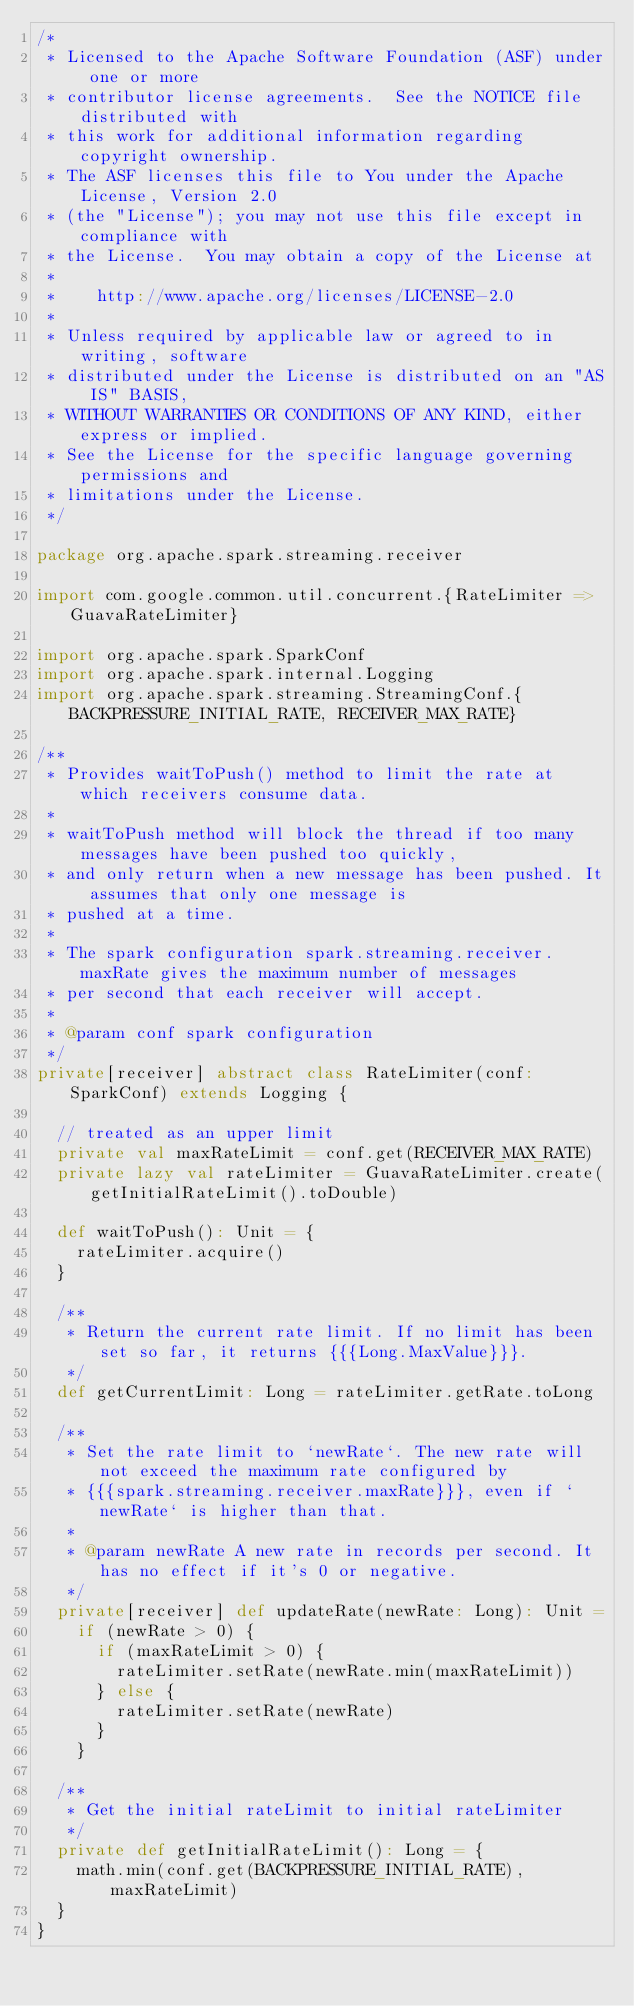<code> <loc_0><loc_0><loc_500><loc_500><_Scala_>/*
 * Licensed to the Apache Software Foundation (ASF) under one or more
 * contributor license agreements.  See the NOTICE file distributed with
 * this work for additional information regarding copyright ownership.
 * The ASF licenses this file to You under the Apache License, Version 2.0
 * (the "License"); you may not use this file except in compliance with
 * the License.  You may obtain a copy of the License at
 *
 *    http://www.apache.org/licenses/LICENSE-2.0
 *
 * Unless required by applicable law or agreed to in writing, software
 * distributed under the License is distributed on an "AS IS" BASIS,
 * WITHOUT WARRANTIES OR CONDITIONS OF ANY KIND, either express or implied.
 * See the License for the specific language governing permissions and
 * limitations under the License.
 */

package org.apache.spark.streaming.receiver

import com.google.common.util.concurrent.{RateLimiter => GuavaRateLimiter}

import org.apache.spark.SparkConf
import org.apache.spark.internal.Logging
import org.apache.spark.streaming.StreamingConf.{BACKPRESSURE_INITIAL_RATE, RECEIVER_MAX_RATE}

/**
 * Provides waitToPush() method to limit the rate at which receivers consume data.
 *
 * waitToPush method will block the thread if too many messages have been pushed too quickly,
 * and only return when a new message has been pushed. It assumes that only one message is
 * pushed at a time.
 *
 * The spark configuration spark.streaming.receiver.maxRate gives the maximum number of messages
 * per second that each receiver will accept.
 *
 * @param conf spark configuration
 */
private[receiver] abstract class RateLimiter(conf: SparkConf) extends Logging {

  // treated as an upper limit
  private val maxRateLimit = conf.get(RECEIVER_MAX_RATE)
  private lazy val rateLimiter = GuavaRateLimiter.create(getInitialRateLimit().toDouble)

  def waitToPush(): Unit = {
    rateLimiter.acquire()
  }

  /**
   * Return the current rate limit. If no limit has been set so far, it returns {{{Long.MaxValue}}}.
   */
  def getCurrentLimit: Long = rateLimiter.getRate.toLong

  /**
   * Set the rate limit to `newRate`. The new rate will not exceed the maximum rate configured by
   * {{{spark.streaming.receiver.maxRate}}}, even if `newRate` is higher than that.
   *
   * @param newRate A new rate in records per second. It has no effect if it's 0 or negative.
   */
  private[receiver] def updateRate(newRate: Long): Unit =
    if (newRate > 0) {
      if (maxRateLimit > 0) {
        rateLimiter.setRate(newRate.min(maxRateLimit))
      } else {
        rateLimiter.setRate(newRate)
      }
    }

  /**
   * Get the initial rateLimit to initial rateLimiter
   */
  private def getInitialRateLimit(): Long = {
    math.min(conf.get(BACKPRESSURE_INITIAL_RATE), maxRateLimit)
  }
}
</code> 